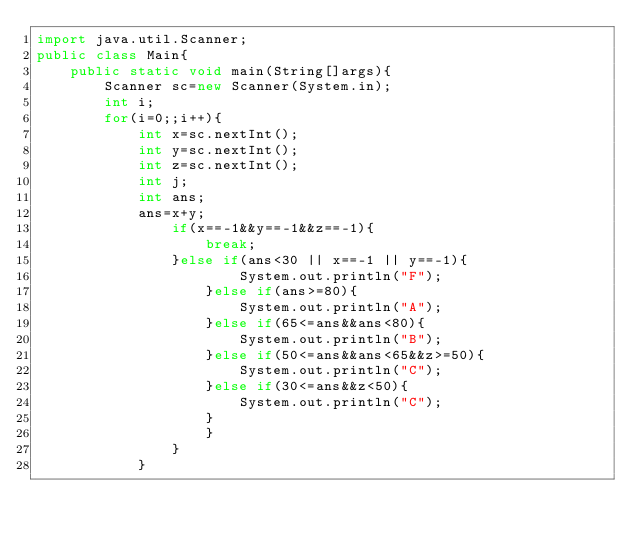Convert code to text. <code><loc_0><loc_0><loc_500><loc_500><_Java_>import java.util.Scanner;
public class Main{
	public static void main(String[]args){
		Scanner sc=new Scanner(System.in);
		int i;
		for(i=0;;i++){
			int x=sc.nextInt();
			int y=sc.nextInt();
			int z=sc.nextInt();
			int j;
			int ans;
			ans=x+y;
				if(x==-1&&y==-1&&z==-1){
					break;
				}else if(ans<30 || x==-1 || y==-1){
						System.out.println("F");
					}else if(ans>=80){
						System.out.println("A");
					}else if(65<=ans&&ans<80){
						System.out.println("B");
					}else if(50<=ans&&ans<65&&z>=50){
						System.out.println("C");
					}else if(30<=ans&&z<50){
						System.out.println("C");
					}
					}
				}
			}</code> 